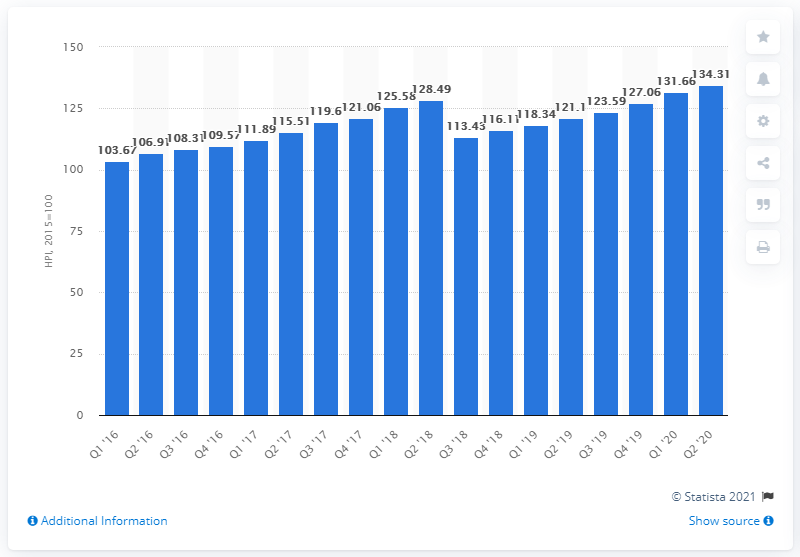Indicate a few pertinent items in this graphic. The house price index in Portugal for the quarter ending June 2020 was 134.31. 